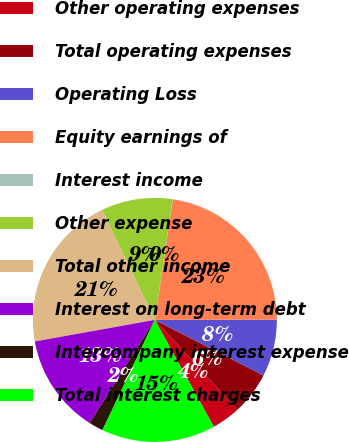Convert chart to OTSL. <chart><loc_0><loc_0><loc_500><loc_500><pie_chart><fcel>Other operating expenses<fcel>Total operating expenses<fcel>Operating Loss<fcel>Equity earnings of<fcel>Interest income<fcel>Other expense<fcel>Total other income<fcel>Interest on long-term debt<fcel>Intercompany interest expense<fcel>Total interest charges<nl><fcel>3.79%<fcel>5.67%<fcel>7.56%<fcel>22.6%<fcel>0.03%<fcel>9.44%<fcel>20.72%<fcel>13.2%<fcel>1.91%<fcel>15.08%<nl></chart> 